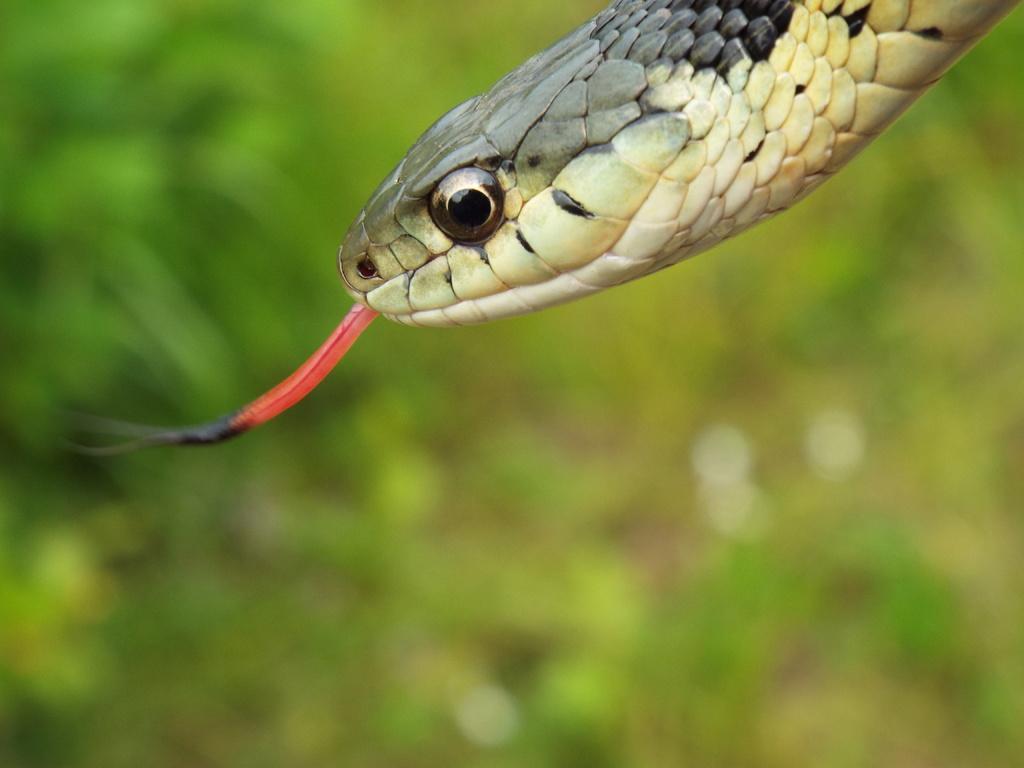Please provide a concise description of this image. In this picture, we can see a snake, and we can see the blurred background. 